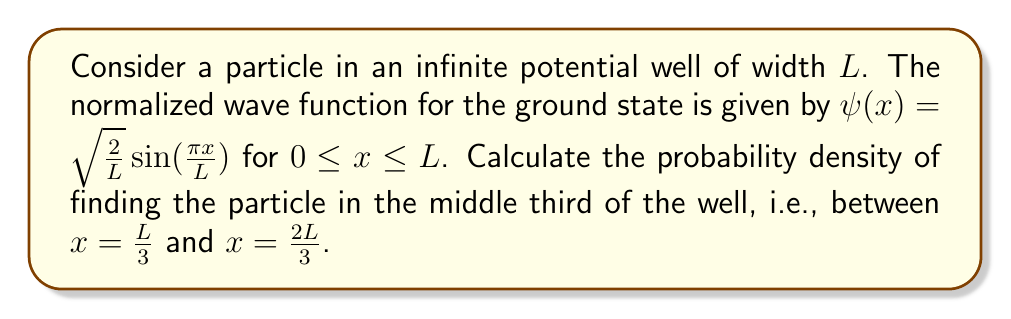Can you solve this math problem? To solve this problem, we need to follow these steps:

1) The probability density is given by $|\psi(x)|^2$. For our wave function:

   $|\psi(x)|^2 = \frac{2}{L} \sin^2(\frac{\pi x}{L})$

2) To find the probability of the particle being in a specific region, we need to integrate the probability density over that region:

   $P = \int_{\frac{L}{3}}^{\frac{2L}{3}} |\psi(x)|^2 dx$

3) Substituting our probability density:

   $P = \int_{\frac{L}{3}}^{\frac{2L}{3}} \frac{2}{L} \sin^2(\frac{\pi x}{L}) dx$

4) To solve this integral, we can use the trigonometric identity:

   $\sin^2 \theta = \frac{1}{2}(1 - \cos 2\theta)$

5) Applying this to our integral:

   $P = \int_{\frac{L}{3}}^{\frac{2L}{3}} \frac{2}{L} [\frac{1}{2} - \frac{1}{2}\cos(\frac{2\pi x}{L})] dx$

   $= \frac{1}{L} \int_{\frac{L}{3}}^{\frac{2L}{3}} [1 - \cos(\frac{2\pi x}{L})] dx$

6) Integrating:

   $P = [\frac{x}{L} - \frac{L}{2\pi}\sin(\frac{2\pi x}{L})]_{\frac{L}{3}}^{\frac{2L}{3}}$

7) Evaluating the limits:

   $P = [\frac{2L}{3L} - \frac{L}{2\pi}\sin(\frac{4\pi}{3})] - [\frac{L}{3L} - \frac{L}{2\pi}\sin(\frac{2\pi}{3})]$

   $= \frac{1}{3} + \frac{L}{2\pi}[\sin(\frac{2\pi}{3}) - \sin(\frac{4\pi}{3})]$

8) Simplify using $\sin(\frac{4\pi}{3}) = -\sin(\frac{2\pi}{3})$:

   $P = \frac{1}{3} + \frac{L}{2\pi}[2\sin(\frac{2\pi}{3})]$

   $= \frac{1}{3} + \frac{L}{2\pi}[2 \cdot \frac{\sqrt{3}}{2}]$

   $= \frac{1}{3} + \frac{\sqrt{3}}{\pi}$
Answer: $P = \frac{1}{3} + \frac{\sqrt{3}}{\pi} \approx 0.8862$ 